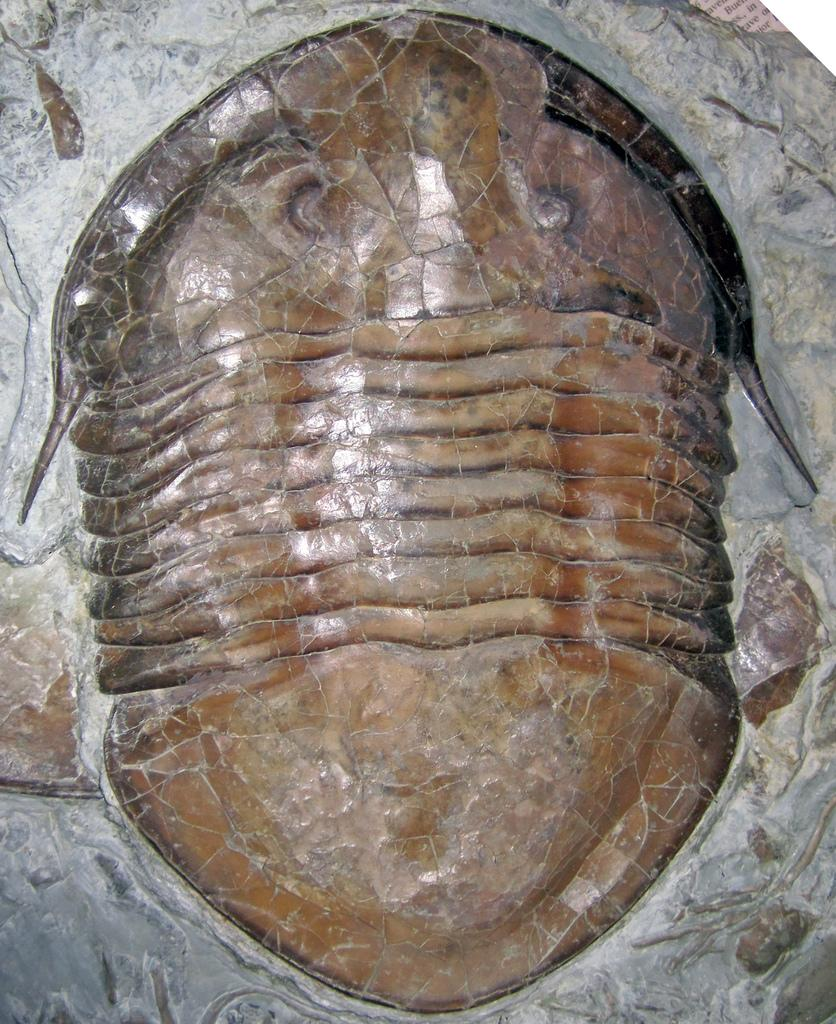What is the main subject of the image? There is a sculpture in the image. What material is the sculpture made of? The sculpture is made of stone. What type of beam is holding up the sculpture in the image? There is no beam present in the image; the sculpture is made of stone and does not require any support. 